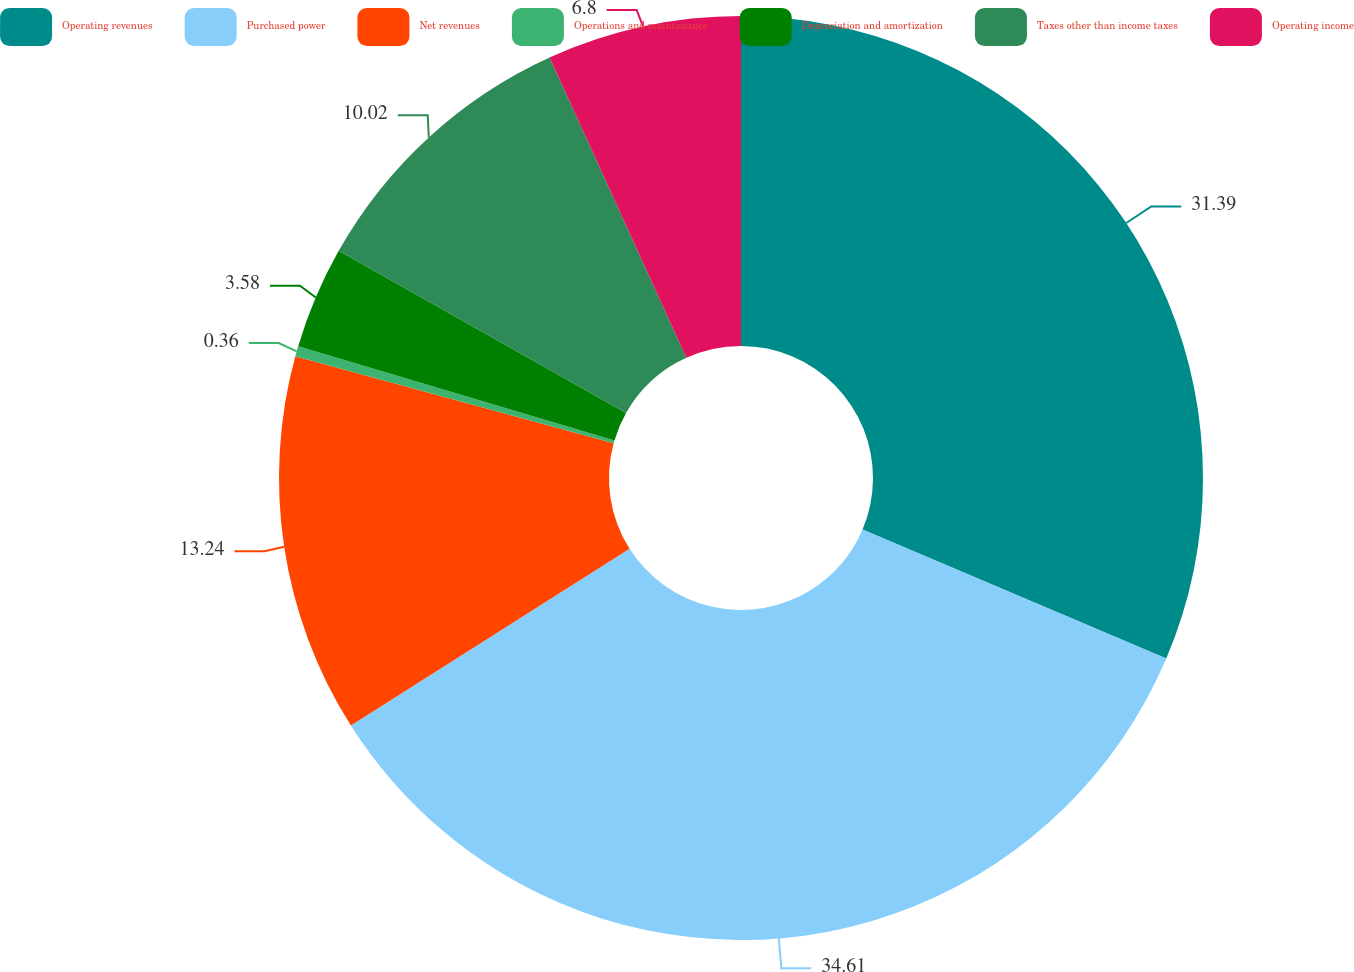<chart> <loc_0><loc_0><loc_500><loc_500><pie_chart><fcel>Operating revenues<fcel>Purchased power<fcel>Net revenues<fcel>Operations and maintenance<fcel>Depreciation and amortization<fcel>Taxes other than income taxes<fcel>Operating income<nl><fcel>31.39%<fcel>34.61%<fcel>13.24%<fcel>0.36%<fcel>3.58%<fcel>10.02%<fcel>6.8%<nl></chart> 